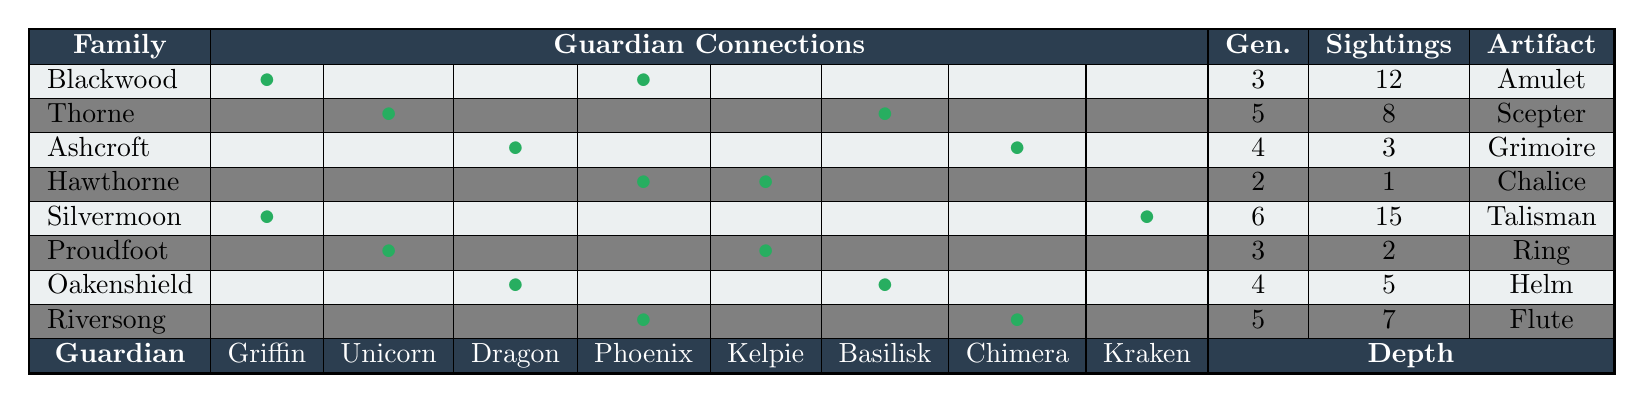What family is associated with the Unicorn guardian? By examining the connections in the table, the Thorne family is marked as connected to the Unicorn guardian (second column).
Answer: Thorne Which family has the most guardian sightings? The sightings for each family are as follows: Blackwood (12), Thorne (8), Ashcroft (3), Hawthorne (1), Silvermoon (15), Proudfoot (2), Oakenshield (5), Riversong (7). The highest number is from Silvermoon with 15 sightings.
Answer: Silvermoon How many guardians are connected to the Blackwood family? The Blackwood family has connections marked to two guardians: Griffin and Phoenix.
Answer: 2 What is the total generation depth of all families combined? The individual depths are 3, 5, 4, 2, 6, 3, 4, and 5. Adding these gives: 3 + 5 + 4 + 2 + 6 + 3 + 4 + 5 = 32.
Answer: 32 Is there a family that has connections to both the Griffin and Phoenix guardians? Checking the connections shows that the Blackwood family has connections to both Griffin and Phoenix, confirmed by the marked entries.
Answer: Yes Which family has the highest generation depth? The generation depths from the table are: 3, 5, 4, 2, 6, 3, 4, 5. The highest value is 6, associated with the Silvermoon family.
Answer: Silvermoon How many families are connected to the Chimera guardian? The connections table shows there are two families linked to the Chimera guardian: Ashcroft and Oakenshield.
Answer: 2 What is the average number of guardian sightings per family? The total sightings are 12, 8, 3, 1, 15, 2, 5, 7, which sum to 53. Dividing this by 8 (the number of families) gives 53 / 8 = 6.625.
Answer: 6.625 Does the Proudfoot family have any connections to the Dragon guardian? Looking at the connections, there is no marking for the Proudfoot family to have a connection with the Dragon guardian, confirming it is not connected.
Answer: No Which family possesses the Ashcroft Grimoire artifact? The tablet shows that the artifact associated with the Ashcroft family is the Ashcroft Grimoire, as listed in the final column.
Answer: Ashcroft 